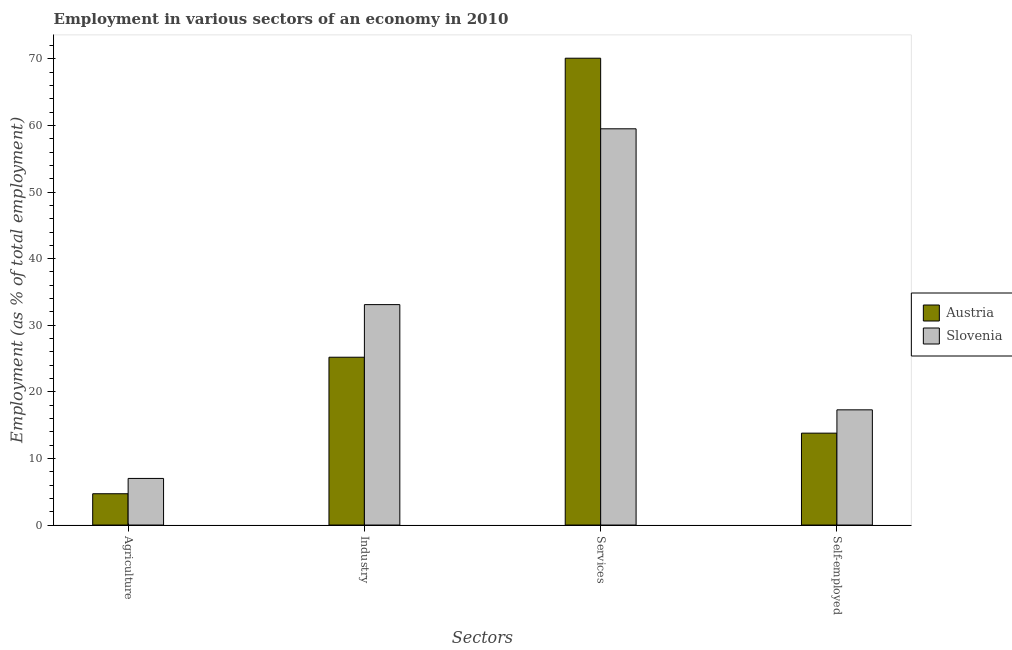How many bars are there on the 1st tick from the left?
Your answer should be very brief. 2. What is the label of the 2nd group of bars from the left?
Provide a succinct answer. Industry. What is the percentage of self employed workers in Slovenia?
Keep it short and to the point. 17.3. Across all countries, what is the minimum percentage of self employed workers?
Your answer should be compact. 13.8. In which country was the percentage of workers in industry maximum?
Your answer should be compact. Slovenia. In which country was the percentage of self employed workers minimum?
Offer a very short reply. Austria. What is the total percentage of self employed workers in the graph?
Make the answer very short. 31.1. What is the difference between the percentage of self employed workers in Slovenia and that in Austria?
Ensure brevity in your answer.  3.5. What is the difference between the percentage of workers in industry in Austria and the percentage of self employed workers in Slovenia?
Provide a succinct answer. 7.9. What is the average percentage of workers in agriculture per country?
Keep it short and to the point. 5.85. What is the difference between the percentage of workers in services and percentage of workers in agriculture in Slovenia?
Your answer should be compact. 52.5. What is the ratio of the percentage of workers in services in Austria to that in Slovenia?
Give a very brief answer. 1.18. Is the percentage of workers in services in Austria less than that in Slovenia?
Your response must be concise. No. Is the difference between the percentage of workers in industry in Austria and Slovenia greater than the difference between the percentage of self employed workers in Austria and Slovenia?
Your response must be concise. No. What is the difference between the highest and the second highest percentage of workers in services?
Your response must be concise. 10.6. What is the difference between the highest and the lowest percentage of workers in services?
Offer a very short reply. 10.6. In how many countries, is the percentage of workers in industry greater than the average percentage of workers in industry taken over all countries?
Your answer should be very brief. 1. Is the sum of the percentage of self employed workers in Slovenia and Austria greater than the maximum percentage of workers in services across all countries?
Your answer should be compact. No. Is it the case that in every country, the sum of the percentage of workers in services and percentage of workers in industry is greater than the sum of percentage of self employed workers and percentage of workers in agriculture?
Provide a short and direct response. Yes. What does the 1st bar from the left in Self-employed represents?
Your answer should be compact. Austria. What does the 1st bar from the right in Self-employed represents?
Your answer should be compact. Slovenia. Is it the case that in every country, the sum of the percentage of workers in agriculture and percentage of workers in industry is greater than the percentage of workers in services?
Keep it short and to the point. No. How many countries are there in the graph?
Offer a very short reply. 2. What is the difference between two consecutive major ticks on the Y-axis?
Your answer should be very brief. 10. Are the values on the major ticks of Y-axis written in scientific E-notation?
Your answer should be compact. No. Does the graph contain any zero values?
Offer a very short reply. No. Where does the legend appear in the graph?
Your answer should be very brief. Center right. How are the legend labels stacked?
Provide a succinct answer. Vertical. What is the title of the graph?
Make the answer very short. Employment in various sectors of an economy in 2010. Does "Guam" appear as one of the legend labels in the graph?
Make the answer very short. No. What is the label or title of the X-axis?
Provide a short and direct response. Sectors. What is the label or title of the Y-axis?
Your answer should be very brief. Employment (as % of total employment). What is the Employment (as % of total employment) of Austria in Agriculture?
Provide a succinct answer. 4.7. What is the Employment (as % of total employment) of Austria in Industry?
Offer a very short reply. 25.2. What is the Employment (as % of total employment) in Slovenia in Industry?
Your answer should be compact. 33.1. What is the Employment (as % of total employment) of Austria in Services?
Provide a short and direct response. 70.1. What is the Employment (as % of total employment) of Slovenia in Services?
Offer a terse response. 59.5. What is the Employment (as % of total employment) in Austria in Self-employed?
Make the answer very short. 13.8. What is the Employment (as % of total employment) in Slovenia in Self-employed?
Offer a terse response. 17.3. Across all Sectors, what is the maximum Employment (as % of total employment) of Austria?
Keep it short and to the point. 70.1. Across all Sectors, what is the maximum Employment (as % of total employment) of Slovenia?
Make the answer very short. 59.5. Across all Sectors, what is the minimum Employment (as % of total employment) of Austria?
Your response must be concise. 4.7. What is the total Employment (as % of total employment) of Austria in the graph?
Ensure brevity in your answer.  113.8. What is the total Employment (as % of total employment) of Slovenia in the graph?
Your response must be concise. 116.9. What is the difference between the Employment (as % of total employment) of Austria in Agriculture and that in Industry?
Provide a short and direct response. -20.5. What is the difference between the Employment (as % of total employment) of Slovenia in Agriculture and that in Industry?
Your answer should be very brief. -26.1. What is the difference between the Employment (as % of total employment) of Austria in Agriculture and that in Services?
Keep it short and to the point. -65.4. What is the difference between the Employment (as % of total employment) of Slovenia in Agriculture and that in Services?
Keep it short and to the point. -52.5. What is the difference between the Employment (as % of total employment) of Austria in Agriculture and that in Self-employed?
Ensure brevity in your answer.  -9.1. What is the difference between the Employment (as % of total employment) of Austria in Industry and that in Services?
Ensure brevity in your answer.  -44.9. What is the difference between the Employment (as % of total employment) in Slovenia in Industry and that in Services?
Your answer should be compact. -26.4. What is the difference between the Employment (as % of total employment) in Austria in Services and that in Self-employed?
Ensure brevity in your answer.  56.3. What is the difference between the Employment (as % of total employment) in Slovenia in Services and that in Self-employed?
Offer a very short reply. 42.2. What is the difference between the Employment (as % of total employment) of Austria in Agriculture and the Employment (as % of total employment) of Slovenia in Industry?
Your response must be concise. -28.4. What is the difference between the Employment (as % of total employment) of Austria in Agriculture and the Employment (as % of total employment) of Slovenia in Services?
Provide a short and direct response. -54.8. What is the difference between the Employment (as % of total employment) of Austria in Agriculture and the Employment (as % of total employment) of Slovenia in Self-employed?
Ensure brevity in your answer.  -12.6. What is the difference between the Employment (as % of total employment) in Austria in Industry and the Employment (as % of total employment) in Slovenia in Services?
Your response must be concise. -34.3. What is the difference between the Employment (as % of total employment) of Austria in Services and the Employment (as % of total employment) of Slovenia in Self-employed?
Your answer should be very brief. 52.8. What is the average Employment (as % of total employment) in Austria per Sectors?
Ensure brevity in your answer.  28.45. What is the average Employment (as % of total employment) in Slovenia per Sectors?
Provide a succinct answer. 29.23. What is the difference between the Employment (as % of total employment) of Austria and Employment (as % of total employment) of Slovenia in Agriculture?
Keep it short and to the point. -2.3. What is the difference between the Employment (as % of total employment) of Austria and Employment (as % of total employment) of Slovenia in Services?
Make the answer very short. 10.6. What is the difference between the Employment (as % of total employment) of Austria and Employment (as % of total employment) of Slovenia in Self-employed?
Keep it short and to the point. -3.5. What is the ratio of the Employment (as % of total employment) in Austria in Agriculture to that in Industry?
Offer a very short reply. 0.19. What is the ratio of the Employment (as % of total employment) in Slovenia in Agriculture to that in Industry?
Ensure brevity in your answer.  0.21. What is the ratio of the Employment (as % of total employment) of Austria in Agriculture to that in Services?
Your response must be concise. 0.07. What is the ratio of the Employment (as % of total employment) in Slovenia in Agriculture to that in Services?
Offer a terse response. 0.12. What is the ratio of the Employment (as % of total employment) of Austria in Agriculture to that in Self-employed?
Provide a short and direct response. 0.34. What is the ratio of the Employment (as % of total employment) in Slovenia in Agriculture to that in Self-employed?
Give a very brief answer. 0.4. What is the ratio of the Employment (as % of total employment) of Austria in Industry to that in Services?
Ensure brevity in your answer.  0.36. What is the ratio of the Employment (as % of total employment) of Slovenia in Industry to that in Services?
Your response must be concise. 0.56. What is the ratio of the Employment (as % of total employment) in Austria in Industry to that in Self-employed?
Your answer should be very brief. 1.83. What is the ratio of the Employment (as % of total employment) in Slovenia in Industry to that in Self-employed?
Make the answer very short. 1.91. What is the ratio of the Employment (as % of total employment) of Austria in Services to that in Self-employed?
Make the answer very short. 5.08. What is the ratio of the Employment (as % of total employment) in Slovenia in Services to that in Self-employed?
Your answer should be compact. 3.44. What is the difference between the highest and the second highest Employment (as % of total employment) of Austria?
Provide a short and direct response. 44.9. What is the difference between the highest and the second highest Employment (as % of total employment) in Slovenia?
Give a very brief answer. 26.4. What is the difference between the highest and the lowest Employment (as % of total employment) in Austria?
Your answer should be compact. 65.4. What is the difference between the highest and the lowest Employment (as % of total employment) in Slovenia?
Your answer should be very brief. 52.5. 